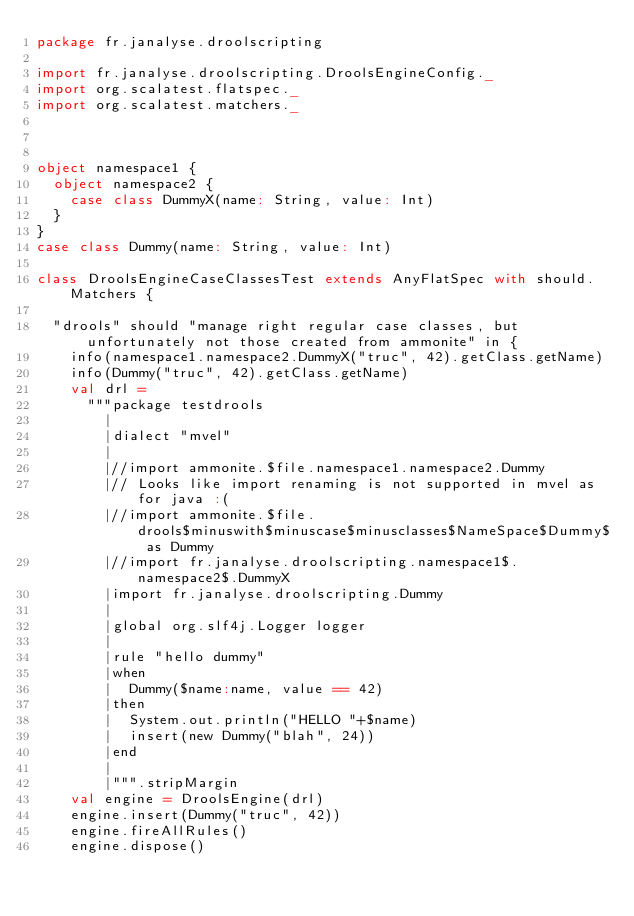Convert code to text. <code><loc_0><loc_0><loc_500><loc_500><_Scala_>package fr.janalyse.droolscripting

import fr.janalyse.droolscripting.DroolsEngineConfig._
import org.scalatest.flatspec._
import org.scalatest.matchers._



object namespace1 {
  object namespace2 {
    case class DummyX(name: String, value: Int)
  }
}
case class Dummy(name: String, value: Int)

class DroolsEngineCaseClassesTest extends AnyFlatSpec with should.Matchers {

  "drools" should "manage right regular case classes, but unfortunately not those created from ammonite" in {
    info(namespace1.namespace2.DummyX("truc", 42).getClass.getName)
    info(Dummy("truc", 42).getClass.getName)
    val drl =
      """package testdrools
        |
        |dialect "mvel"
        |
        |//import ammonite.$file.namespace1.namespace2.Dummy
        |// Looks like import renaming is not supported in mvel as for java :(
        |//import ammonite.$file.drools$minuswith$minuscase$minusclasses$NameSpace$Dummy$ as Dummy
        |//import fr.janalyse.droolscripting.namespace1$.namespace2$.DummyX
        |import fr.janalyse.droolscripting.Dummy
        |
        |global org.slf4j.Logger logger
        |
        |rule "hello dummy"
        |when
        |  Dummy($name:name, value == 42)
        |then
        |  System.out.println("HELLO "+$name)
        |  insert(new Dummy("blah", 24))
        |end
        |
        |""".stripMargin
    val engine = DroolsEngine(drl)
    engine.insert(Dummy("truc", 42))
    engine.fireAllRules()
    engine.dispose()</code> 